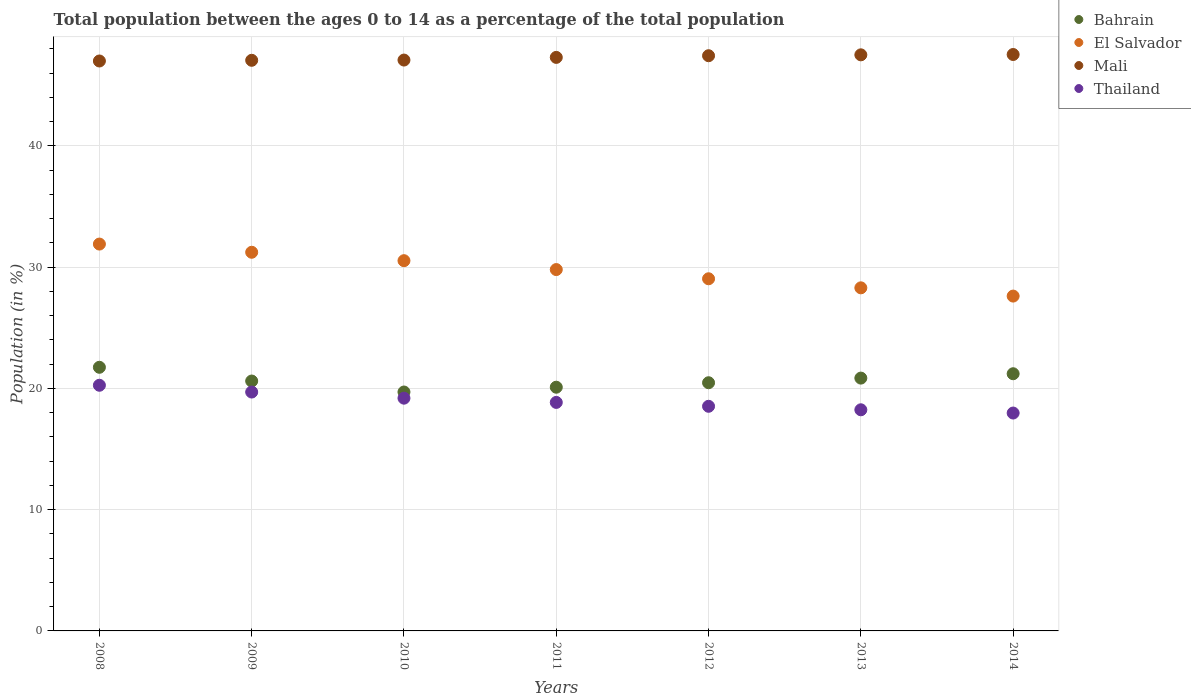What is the percentage of the population ages 0 to 14 in Mali in 2010?
Give a very brief answer. 47.08. Across all years, what is the maximum percentage of the population ages 0 to 14 in Thailand?
Provide a succinct answer. 20.26. Across all years, what is the minimum percentage of the population ages 0 to 14 in Thailand?
Your answer should be very brief. 17.97. What is the total percentage of the population ages 0 to 14 in Bahrain in the graph?
Your answer should be compact. 144.69. What is the difference between the percentage of the population ages 0 to 14 in Bahrain in 2009 and that in 2014?
Offer a terse response. -0.6. What is the difference between the percentage of the population ages 0 to 14 in Thailand in 2010 and the percentage of the population ages 0 to 14 in Bahrain in 2012?
Keep it short and to the point. -1.27. What is the average percentage of the population ages 0 to 14 in Bahrain per year?
Your response must be concise. 20.67. In the year 2014, what is the difference between the percentage of the population ages 0 to 14 in El Salvador and percentage of the population ages 0 to 14 in Mali?
Offer a terse response. -19.92. What is the ratio of the percentage of the population ages 0 to 14 in Mali in 2009 to that in 2010?
Keep it short and to the point. 1. Is the percentage of the population ages 0 to 14 in El Salvador in 2008 less than that in 2014?
Offer a terse response. No. Is the difference between the percentage of the population ages 0 to 14 in El Salvador in 2010 and 2012 greater than the difference between the percentage of the population ages 0 to 14 in Mali in 2010 and 2012?
Make the answer very short. Yes. What is the difference between the highest and the second highest percentage of the population ages 0 to 14 in El Salvador?
Give a very brief answer. 0.68. What is the difference between the highest and the lowest percentage of the population ages 0 to 14 in Mali?
Ensure brevity in your answer.  0.54. In how many years, is the percentage of the population ages 0 to 14 in Bahrain greater than the average percentage of the population ages 0 to 14 in Bahrain taken over all years?
Offer a terse response. 3. Does the percentage of the population ages 0 to 14 in Bahrain monotonically increase over the years?
Offer a very short reply. No. How many years are there in the graph?
Provide a succinct answer. 7. What is the difference between two consecutive major ticks on the Y-axis?
Your answer should be compact. 10. Are the values on the major ticks of Y-axis written in scientific E-notation?
Provide a succinct answer. No. Does the graph contain grids?
Offer a terse response. Yes. Where does the legend appear in the graph?
Keep it short and to the point. Top right. How many legend labels are there?
Make the answer very short. 4. How are the legend labels stacked?
Your answer should be compact. Vertical. What is the title of the graph?
Your answer should be compact. Total population between the ages 0 to 14 as a percentage of the total population. What is the label or title of the X-axis?
Provide a short and direct response. Years. What is the label or title of the Y-axis?
Your answer should be very brief. Population (in %). What is the Population (in %) in Bahrain in 2008?
Offer a terse response. 21.74. What is the Population (in %) of El Salvador in 2008?
Your answer should be compact. 31.91. What is the Population (in %) of Mali in 2008?
Your answer should be very brief. 47. What is the Population (in %) in Thailand in 2008?
Offer a very short reply. 20.26. What is the Population (in %) in Bahrain in 2009?
Provide a succinct answer. 20.61. What is the Population (in %) of El Salvador in 2009?
Your answer should be compact. 31.23. What is the Population (in %) of Mali in 2009?
Make the answer very short. 47.06. What is the Population (in %) of Thailand in 2009?
Offer a very short reply. 19.7. What is the Population (in %) of Bahrain in 2010?
Your answer should be very brief. 19.7. What is the Population (in %) in El Salvador in 2010?
Provide a succinct answer. 30.53. What is the Population (in %) of Mali in 2010?
Make the answer very short. 47.08. What is the Population (in %) of Thailand in 2010?
Give a very brief answer. 19.2. What is the Population (in %) in Bahrain in 2011?
Your answer should be compact. 20.1. What is the Population (in %) of El Salvador in 2011?
Your response must be concise. 29.8. What is the Population (in %) in Mali in 2011?
Keep it short and to the point. 47.3. What is the Population (in %) of Thailand in 2011?
Keep it short and to the point. 18.85. What is the Population (in %) of Bahrain in 2012?
Make the answer very short. 20.47. What is the Population (in %) of El Salvador in 2012?
Keep it short and to the point. 29.04. What is the Population (in %) of Mali in 2012?
Give a very brief answer. 47.44. What is the Population (in %) in Thailand in 2012?
Keep it short and to the point. 18.53. What is the Population (in %) in Bahrain in 2013?
Offer a very short reply. 20.85. What is the Population (in %) in El Salvador in 2013?
Give a very brief answer. 28.3. What is the Population (in %) in Mali in 2013?
Ensure brevity in your answer.  47.51. What is the Population (in %) of Thailand in 2013?
Ensure brevity in your answer.  18.24. What is the Population (in %) of Bahrain in 2014?
Give a very brief answer. 21.21. What is the Population (in %) in El Salvador in 2014?
Give a very brief answer. 27.62. What is the Population (in %) in Mali in 2014?
Give a very brief answer. 47.54. What is the Population (in %) in Thailand in 2014?
Provide a short and direct response. 17.97. Across all years, what is the maximum Population (in %) of Bahrain?
Offer a terse response. 21.74. Across all years, what is the maximum Population (in %) in El Salvador?
Your answer should be very brief. 31.91. Across all years, what is the maximum Population (in %) in Mali?
Provide a succinct answer. 47.54. Across all years, what is the maximum Population (in %) of Thailand?
Make the answer very short. 20.26. Across all years, what is the minimum Population (in %) of Bahrain?
Give a very brief answer. 19.7. Across all years, what is the minimum Population (in %) in El Salvador?
Your answer should be compact. 27.62. Across all years, what is the minimum Population (in %) of Mali?
Make the answer very short. 47. Across all years, what is the minimum Population (in %) of Thailand?
Your answer should be compact. 17.97. What is the total Population (in %) in Bahrain in the graph?
Provide a succinct answer. 144.69. What is the total Population (in %) in El Salvador in the graph?
Ensure brevity in your answer.  208.42. What is the total Population (in %) of Mali in the graph?
Make the answer very short. 330.94. What is the total Population (in %) of Thailand in the graph?
Offer a terse response. 132.74. What is the difference between the Population (in %) in Bahrain in 2008 and that in 2009?
Provide a short and direct response. 1.13. What is the difference between the Population (in %) of El Salvador in 2008 and that in 2009?
Your answer should be very brief. 0.68. What is the difference between the Population (in %) of Mali in 2008 and that in 2009?
Keep it short and to the point. -0.06. What is the difference between the Population (in %) of Thailand in 2008 and that in 2009?
Make the answer very short. 0.56. What is the difference between the Population (in %) of Bahrain in 2008 and that in 2010?
Offer a terse response. 2.04. What is the difference between the Population (in %) in El Salvador in 2008 and that in 2010?
Provide a short and direct response. 1.37. What is the difference between the Population (in %) of Mali in 2008 and that in 2010?
Ensure brevity in your answer.  -0.08. What is the difference between the Population (in %) of Thailand in 2008 and that in 2010?
Make the answer very short. 1.07. What is the difference between the Population (in %) of Bahrain in 2008 and that in 2011?
Give a very brief answer. 1.64. What is the difference between the Population (in %) of El Salvador in 2008 and that in 2011?
Offer a very short reply. 2.1. What is the difference between the Population (in %) of Mali in 2008 and that in 2011?
Ensure brevity in your answer.  -0.3. What is the difference between the Population (in %) in Thailand in 2008 and that in 2011?
Make the answer very short. 1.41. What is the difference between the Population (in %) of Bahrain in 2008 and that in 2012?
Your answer should be compact. 1.27. What is the difference between the Population (in %) in El Salvador in 2008 and that in 2012?
Keep it short and to the point. 2.86. What is the difference between the Population (in %) in Mali in 2008 and that in 2012?
Ensure brevity in your answer.  -0.43. What is the difference between the Population (in %) of Thailand in 2008 and that in 2012?
Provide a short and direct response. 1.73. What is the difference between the Population (in %) of Bahrain in 2008 and that in 2013?
Make the answer very short. 0.89. What is the difference between the Population (in %) of El Salvador in 2008 and that in 2013?
Your answer should be very brief. 3.61. What is the difference between the Population (in %) of Mali in 2008 and that in 2013?
Keep it short and to the point. -0.51. What is the difference between the Population (in %) in Thailand in 2008 and that in 2013?
Offer a very short reply. 2.02. What is the difference between the Population (in %) of Bahrain in 2008 and that in 2014?
Offer a very short reply. 0.53. What is the difference between the Population (in %) of El Salvador in 2008 and that in 2014?
Your answer should be compact. 4.29. What is the difference between the Population (in %) of Mali in 2008 and that in 2014?
Give a very brief answer. -0.54. What is the difference between the Population (in %) of Thailand in 2008 and that in 2014?
Ensure brevity in your answer.  2.29. What is the difference between the Population (in %) in Bahrain in 2009 and that in 2010?
Keep it short and to the point. 0.91. What is the difference between the Population (in %) in El Salvador in 2009 and that in 2010?
Offer a terse response. 0.69. What is the difference between the Population (in %) in Mali in 2009 and that in 2010?
Your response must be concise. -0.02. What is the difference between the Population (in %) in Thailand in 2009 and that in 2010?
Your answer should be very brief. 0.51. What is the difference between the Population (in %) of Bahrain in 2009 and that in 2011?
Keep it short and to the point. 0.51. What is the difference between the Population (in %) of El Salvador in 2009 and that in 2011?
Offer a very short reply. 1.43. What is the difference between the Population (in %) in Mali in 2009 and that in 2011?
Give a very brief answer. -0.24. What is the difference between the Population (in %) of Thailand in 2009 and that in 2011?
Ensure brevity in your answer.  0.86. What is the difference between the Population (in %) of Bahrain in 2009 and that in 2012?
Provide a succinct answer. 0.14. What is the difference between the Population (in %) of El Salvador in 2009 and that in 2012?
Your answer should be compact. 2.19. What is the difference between the Population (in %) of Mali in 2009 and that in 2012?
Your answer should be very brief. -0.38. What is the difference between the Population (in %) of Thailand in 2009 and that in 2012?
Your response must be concise. 1.17. What is the difference between the Population (in %) in Bahrain in 2009 and that in 2013?
Give a very brief answer. -0.24. What is the difference between the Population (in %) of El Salvador in 2009 and that in 2013?
Keep it short and to the point. 2.93. What is the difference between the Population (in %) of Mali in 2009 and that in 2013?
Keep it short and to the point. -0.45. What is the difference between the Population (in %) in Thailand in 2009 and that in 2013?
Your answer should be compact. 1.46. What is the difference between the Population (in %) in Bahrain in 2009 and that in 2014?
Keep it short and to the point. -0.6. What is the difference between the Population (in %) in El Salvador in 2009 and that in 2014?
Keep it short and to the point. 3.61. What is the difference between the Population (in %) of Mali in 2009 and that in 2014?
Ensure brevity in your answer.  -0.48. What is the difference between the Population (in %) of Thailand in 2009 and that in 2014?
Provide a short and direct response. 1.73. What is the difference between the Population (in %) in Bahrain in 2010 and that in 2011?
Provide a short and direct response. -0.39. What is the difference between the Population (in %) in El Salvador in 2010 and that in 2011?
Your response must be concise. 0.73. What is the difference between the Population (in %) of Mali in 2010 and that in 2011?
Keep it short and to the point. -0.22. What is the difference between the Population (in %) of Thailand in 2010 and that in 2011?
Give a very brief answer. 0.35. What is the difference between the Population (in %) in Bahrain in 2010 and that in 2012?
Provide a succinct answer. -0.76. What is the difference between the Population (in %) of El Salvador in 2010 and that in 2012?
Offer a very short reply. 1.49. What is the difference between the Population (in %) in Mali in 2010 and that in 2012?
Offer a terse response. -0.36. What is the difference between the Population (in %) in Thailand in 2010 and that in 2012?
Provide a short and direct response. 0.67. What is the difference between the Population (in %) in Bahrain in 2010 and that in 2013?
Provide a short and direct response. -1.15. What is the difference between the Population (in %) in El Salvador in 2010 and that in 2013?
Provide a succinct answer. 2.24. What is the difference between the Population (in %) of Mali in 2010 and that in 2013?
Provide a short and direct response. -0.43. What is the difference between the Population (in %) in Thailand in 2010 and that in 2013?
Offer a very short reply. 0.96. What is the difference between the Population (in %) of Bahrain in 2010 and that in 2014?
Ensure brevity in your answer.  -1.51. What is the difference between the Population (in %) in El Salvador in 2010 and that in 2014?
Keep it short and to the point. 2.92. What is the difference between the Population (in %) in Mali in 2010 and that in 2014?
Provide a succinct answer. -0.46. What is the difference between the Population (in %) in Thailand in 2010 and that in 2014?
Provide a short and direct response. 1.23. What is the difference between the Population (in %) of Bahrain in 2011 and that in 2012?
Keep it short and to the point. -0.37. What is the difference between the Population (in %) of El Salvador in 2011 and that in 2012?
Ensure brevity in your answer.  0.76. What is the difference between the Population (in %) in Mali in 2011 and that in 2012?
Give a very brief answer. -0.14. What is the difference between the Population (in %) in Thailand in 2011 and that in 2012?
Your response must be concise. 0.32. What is the difference between the Population (in %) in Bahrain in 2011 and that in 2013?
Your response must be concise. -0.75. What is the difference between the Population (in %) in El Salvador in 2011 and that in 2013?
Offer a very short reply. 1.51. What is the difference between the Population (in %) in Mali in 2011 and that in 2013?
Provide a succinct answer. -0.21. What is the difference between the Population (in %) of Thailand in 2011 and that in 2013?
Make the answer very short. 0.61. What is the difference between the Population (in %) of Bahrain in 2011 and that in 2014?
Provide a short and direct response. -1.11. What is the difference between the Population (in %) in El Salvador in 2011 and that in 2014?
Keep it short and to the point. 2.19. What is the difference between the Population (in %) of Mali in 2011 and that in 2014?
Your response must be concise. -0.24. What is the difference between the Population (in %) of Thailand in 2011 and that in 2014?
Provide a short and direct response. 0.88. What is the difference between the Population (in %) in Bahrain in 2012 and that in 2013?
Your response must be concise. -0.38. What is the difference between the Population (in %) in El Salvador in 2012 and that in 2013?
Ensure brevity in your answer.  0.75. What is the difference between the Population (in %) in Mali in 2012 and that in 2013?
Your response must be concise. -0.07. What is the difference between the Population (in %) in Thailand in 2012 and that in 2013?
Give a very brief answer. 0.29. What is the difference between the Population (in %) in Bahrain in 2012 and that in 2014?
Your response must be concise. -0.74. What is the difference between the Population (in %) of El Salvador in 2012 and that in 2014?
Keep it short and to the point. 1.43. What is the difference between the Population (in %) of Mali in 2012 and that in 2014?
Your answer should be very brief. -0.1. What is the difference between the Population (in %) of Thailand in 2012 and that in 2014?
Your response must be concise. 0.56. What is the difference between the Population (in %) in Bahrain in 2013 and that in 2014?
Your answer should be very brief. -0.36. What is the difference between the Population (in %) of El Salvador in 2013 and that in 2014?
Offer a very short reply. 0.68. What is the difference between the Population (in %) of Mali in 2013 and that in 2014?
Provide a short and direct response. -0.03. What is the difference between the Population (in %) of Thailand in 2013 and that in 2014?
Offer a very short reply. 0.27. What is the difference between the Population (in %) in Bahrain in 2008 and the Population (in %) in El Salvador in 2009?
Keep it short and to the point. -9.49. What is the difference between the Population (in %) of Bahrain in 2008 and the Population (in %) of Mali in 2009?
Give a very brief answer. -25.32. What is the difference between the Population (in %) in Bahrain in 2008 and the Population (in %) in Thailand in 2009?
Provide a short and direct response. 2.04. What is the difference between the Population (in %) in El Salvador in 2008 and the Population (in %) in Mali in 2009?
Make the answer very short. -15.16. What is the difference between the Population (in %) in El Salvador in 2008 and the Population (in %) in Thailand in 2009?
Offer a very short reply. 12.2. What is the difference between the Population (in %) in Mali in 2008 and the Population (in %) in Thailand in 2009?
Ensure brevity in your answer.  27.3. What is the difference between the Population (in %) of Bahrain in 2008 and the Population (in %) of El Salvador in 2010?
Your answer should be very brief. -8.79. What is the difference between the Population (in %) in Bahrain in 2008 and the Population (in %) in Mali in 2010?
Offer a terse response. -25.34. What is the difference between the Population (in %) in Bahrain in 2008 and the Population (in %) in Thailand in 2010?
Your answer should be very brief. 2.55. What is the difference between the Population (in %) in El Salvador in 2008 and the Population (in %) in Mali in 2010?
Give a very brief answer. -15.18. What is the difference between the Population (in %) in El Salvador in 2008 and the Population (in %) in Thailand in 2010?
Offer a very short reply. 12.71. What is the difference between the Population (in %) of Mali in 2008 and the Population (in %) of Thailand in 2010?
Your answer should be compact. 27.81. What is the difference between the Population (in %) in Bahrain in 2008 and the Population (in %) in El Salvador in 2011?
Provide a short and direct response. -8.06. What is the difference between the Population (in %) of Bahrain in 2008 and the Population (in %) of Mali in 2011?
Give a very brief answer. -25.56. What is the difference between the Population (in %) of Bahrain in 2008 and the Population (in %) of Thailand in 2011?
Provide a short and direct response. 2.9. What is the difference between the Population (in %) of El Salvador in 2008 and the Population (in %) of Mali in 2011?
Your answer should be very brief. -15.4. What is the difference between the Population (in %) of El Salvador in 2008 and the Population (in %) of Thailand in 2011?
Give a very brief answer. 13.06. What is the difference between the Population (in %) in Mali in 2008 and the Population (in %) in Thailand in 2011?
Keep it short and to the point. 28.16. What is the difference between the Population (in %) of Bahrain in 2008 and the Population (in %) of El Salvador in 2012?
Keep it short and to the point. -7.3. What is the difference between the Population (in %) of Bahrain in 2008 and the Population (in %) of Mali in 2012?
Keep it short and to the point. -25.7. What is the difference between the Population (in %) of Bahrain in 2008 and the Population (in %) of Thailand in 2012?
Your answer should be compact. 3.22. What is the difference between the Population (in %) in El Salvador in 2008 and the Population (in %) in Mali in 2012?
Keep it short and to the point. -15.53. What is the difference between the Population (in %) of El Salvador in 2008 and the Population (in %) of Thailand in 2012?
Your answer should be compact. 13.38. What is the difference between the Population (in %) in Mali in 2008 and the Population (in %) in Thailand in 2012?
Ensure brevity in your answer.  28.48. What is the difference between the Population (in %) in Bahrain in 2008 and the Population (in %) in El Salvador in 2013?
Ensure brevity in your answer.  -6.55. What is the difference between the Population (in %) in Bahrain in 2008 and the Population (in %) in Mali in 2013?
Your answer should be compact. -25.77. What is the difference between the Population (in %) of Bahrain in 2008 and the Population (in %) of Thailand in 2013?
Make the answer very short. 3.51. What is the difference between the Population (in %) in El Salvador in 2008 and the Population (in %) in Mali in 2013?
Your answer should be compact. -15.61. What is the difference between the Population (in %) in El Salvador in 2008 and the Population (in %) in Thailand in 2013?
Give a very brief answer. 13.67. What is the difference between the Population (in %) in Mali in 2008 and the Population (in %) in Thailand in 2013?
Your response must be concise. 28.77. What is the difference between the Population (in %) in Bahrain in 2008 and the Population (in %) in El Salvador in 2014?
Your answer should be very brief. -5.87. What is the difference between the Population (in %) of Bahrain in 2008 and the Population (in %) of Mali in 2014?
Ensure brevity in your answer.  -25.8. What is the difference between the Population (in %) in Bahrain in 2008 and the Population (in %) in Thailand in 2014?
Your response must be concise. 3.77. What is the difference between the Population (in %) in El Salvador in 2008 and the Population (in %) in Mali in 2014?
Keep it short and to the point. -15.63. What is the difference between the Population (in %) in El Salvador in 2008 and the Population (in %) in Thailand in 2014?
Your answer should be compact. 13.94. What is the difference between the Population (in %) of Mali in 2008 and the Population (in %) of Thailand in 2014?
Provide a short and direct response. 29.03. What is the difference between the Population (in %) in Bahrain in 2009 and the Population (in %) in El Salvador in 2010?
Ensure brevity in your answer.  -9.93. What is the difference between the Population (in %) in Bahrain in 2009 and the Population (in %) in Mali in 2010?
Offer a very short reply. -26.47. What is the difference between the Population (in %) of Bahrain in 2009 and the Population (in %) of Thailand in 2010?
Ensure brevity in your answer.  1.41. What is the difference between the Population (in %) in El Salvador in 2009 and the Population (in %) in Mali in 2010?
Keep it short and to the point. -15.85. What is the difference between the Population (in %) in El Salvador in 2009 and the Population (in %) in Thailand in 2010?
Your answer should be compact. 12.03. What is the difference between the Population (in %) in Mali in 2009 and the Population (in %) in Thailand in 2010?
Provide a succinct answer. 27.87. What is the difference between the Population (in %) in Bahrain in 2009 and the Population (in %) in El Salvador in 2011?
Provide a succinct answer. -9.19. What is the difference between the Population (in %) of Bahrain in 2009 and the Population (in %) of Mali in 2011?
Ensure brevity in your answer.  -26.69. What is the difference between the Population (in %) in Bahrain in 2009 and the Population (in %) in Thailand in 2011?
Ensure brevity in your answer.  1.76. What is the difference between the Population (in %) of El Salvador in 2009 and the Population (in %) of Mali in 2011?
Keep it short and to the point. -16.07. What is the difference between the Population (in %) of El Salvador in 2009 and the Population (in %) of Thailand in 2011?
Give a very brief answer. 12.38. What is the difference between the Population (in %) in Mali in 2009 and the Population (in %) in Thailand in 2011?
Offer a terse response. 28.22. What is the difference between the Population (in %) of Bahrain in 2009 and the Population (in %) of El Salvador in 2012?
Offer a very short reply. -8.43. What is the difference between the Population (in %) of Bahrain in 2009 and the Population (in %) of Mali in 2012?
Your answer should be compact. -26.83. What is the difference between the Population (in %) of Bahrain in 2009 and the Population (in %) of Thailand in 2012?
Give a very brief answer. 2.08. What is the difference between the Population (in %) in El Salvador in 2009 and the Population (in %) in Mali in 2012?
Provide a short and direct response. -16.21. What is the difference between the Population (in %) of El Salvador in 2009 and the Population (in %) of Thailand in 2012?
Provide a short and direct response. 12.7. What is the difference between the Population (in %) in Mali in 2009 and the Population (in %) in Thailand in 2012?
Provide a succinct answer. 28.53. What is the difference between the Population (in %) in Bahrain in 2009 and the Population (in %) in El Salvador in 2013?
Offer a very short reply. -7.69. What is the difference between the Population (in %) in Bahrain in 2009 and the Population (in %) in Mali in 2013?
Your response must be concise. -26.9. What is the difference between the Population (in %) in Bahrain in 2009 and the Population (in %) in Thailand in 2013?
Your answer should be very brief. 2.37. What is the difference between the Population (in %) of El Salvador in 2009 and the Population (in %) of Mali in 2013?
Make the answer very short. -16.28. What is the difference between the Population (in %) of El Salvador in 2009 and the Population (in %) of Thailand in 2013?
Ensure brevity in your answer.  12.99. What is the difference between the Population (in %) in Mali in 2009 and the Population (in %) in Thailand in 2013?
Your answer should be very brief. 28.82. What is the difference between the Population (in %) of Bahrain in 2009 and the Population (in %) of El Salvador in 2014?
Ensure brevity in your answer.  -7.01. What is the difference between the Population (in %) of Bahrain in 2009 and the Population (in %) of Mali in 2014?
Offer a very short reply. -26.93. What is the difference between the Population (in %) of Bahrain in 2009 and the Population (in %) of Thailand in 2014?
Provide a short and direct response. 2.64. What is the difference between the Population (in %) in El Salvador in 2009 and the Population (in %) in Mali in 2014?
Keep it short and to the point. -16.31. What is the difference between the Population (in %) of El Salvador in 2009 and the Population (in %) of Thailand in 2014?
Ensure brevity in your answer.  13.26. What is the difference between the Population (in %) of Mali in 2009 and the Population (in %) of Thailand in 2014?
Keep it short and to the point. 29.09. What is the difference between the Population (in %) of Bahrain in 2010 and the Population (in %) of El Salvador in 2011?
Your answer should be compact. -10.1. What is the difference between the Population (in %) of Bahrain in 2010 and the Population (in %) of Mali in 2011?
Make the answer very short. -27.6. What is the difference between the Population (in %) of Bahrain in 2010 and the Population (in %) of Thailand in 2011?
Your answer should be very brief. 0.86. What is the difference between the Population (in %) in El Salvador in 2010 and the Population (in %) in Mali in 2011?
Offer a very short reply. -16.77. What is the difference between the Population (in %) in El Salvador in 2010 and the Population (in %) in Thailand in 2011?
Keep it short and to the point. 11.69. What is the difference between the Population (in %) in Mali in 2010 and the Population (in %) in Thailand in 2011?
Provide a succinct answer. 28.24. What is the difference between the Population (in %) of Bahrain in 2010 and the Population (in %) of El Salvador in 2012?
Keep it short and to the point. -9.34. What is the difference between the Population (in %) in Bahrain in 2010 and the Population (in %) in Mali in 2012?
Keep it short and to the point. -27.73. What is the difference between the Population (in %) in Bahrain in 2010 and the Population (in %) in Thailand in 2012?
Make the answer very short. 1.18. What is the difference between the Population (in %) in El Salvador in 2010 and the Population (in %) in Mali in 2012?
Your answer should be very brief. -16.9. What is the difference between the Population (in %) of El Salvador in 2010 and the Population (in %) of Thailand in 2012?
Your answer should be very brief. 12.01. What is the difference between the Population (in %) in Mali in 2010 and the Population (in %) in Thailand in 2012?
Your answer should be compact. 28.55. What is the difference between the Population (in %) in Bahrain in 2010 and the Population (in %) in El Salvador in 2013?
Offer a terse response. -8.59. What is the difference between the Population (in %) in Bahrain in 2010 and the Population (in %) in Mali in 2013?
Offer a very short reply. -27.81. What is the difference between the Population (in %) of Bahrain in 2010 and the Population (in %) of Thailand in 2013?
Your answer should be very brief. 1.47. What is the difference between the Population (in %) in El Salvador in 2010 and the Population (in %) in Mali in 2013?
Your response must be concise. -16.98. What is the difference between the Population (in %) in El Salvador in 2010 and the Population (in %) in Thailand in 2013?
Your answer should be very brief. 12.3. What is the difference between the Population (in %) in Mali in 2010 and the Population (in %) in Thailand in 2013?
Offer a terse response. 28.84. What is the difference between the Population (in %) in Bahrain in 2010 and the Population (in %) in El Salvador in 2014?
Offer a terse response. -7.91. What is the difference between the Population (in %) in Bahrain in 2010 and the Population (in %) in Mali in 2014?
Ensure brevity in your answer.  -27.83. What is the difference between the Population (in %) of Bahrain in 2010 and the Population (in %) of Thailand in 2014?
Provide a short and direct response. 1.73. What is the difference between the Population (in %) in El Salvador in 2010 and the Population (in %) in Mali in 2014?
Make the answer very short. -17. What is the difference between the Population (in %) of El Salvador in 2010 and the Population (in %) of Thailand in 2014?
Your answer should be compact. 12.57. What is the difference between the Population (in %) in Mali in 2010 and the Population (in %) in Thailand in 2014?
Your answer should be compact. 29.11. What is the difference between the Population (in %) of Bahrain in 2011 and the Population (in %) of El Salvador in 2012?
Your answer should be compact. -8.94. What is the difference between the Population (in %) of Bahrain in 2011 and the Population (in %) of Mali in 2012?
Provide a succinct answer. -27.34. What is the difference between the Population (in %) of Bahrain in 2011 and the Population (in %) of Thailand in 2012?
Your answer should be very brief. 1.57. What is the difference between the Population (in %) in El Salvador in 2011 and the Population (in %) in Mali in 2012?
Your response must be concise. -17.64. What is the difference between the Population (in %) in El Salvador in 2011 and the Population (in %) in Thailand in 2012?
Provide a short and direct response. 11.28. What is the difference between the Population (in %) of Mali in 2011 and the Population (in %) of Thailand in 2012?
Keep it short and to the point. 28.77. What is the difference between the Population (in %) of Bahrain in 2011 and the Population (in %) of El Salvador in 2013?
Keep it short and to the point. -8.2. What is the difference between the Population (in %) of Bahrain in 2011 and the Population (in %) of Mali in 2013?
Offer a terse response. -27.41. What is the difference between the Population (in %) of Bahrain in 2011 and the Population (in %) of Thailand in 2013?
Your answer should be very brief. 1.86. What is the difference between the Population (in %) in El Salvador in 2011 and the Population (in %) in Mali in 2013?
Ensure brevity in your answer.  -17.71. What is the difference between the Population (in %) of El Salvador in 2011 and the Population (in %) of Thailand in 2013?
Offer a terse response. 11.56. What is the difference between the Population (in %) in Mali in 2011 and the Population (in %) in Thailand in 2013?
Your answer should be compact. 29.06. What is the difference between the Population (in %) in Bahrain in 2011 and the Population (in %) in El Salvador in 2014?
Your response must be concise. -7.52. What is the difference between the Population (in %) of Bahrain in 2011 and the Population (in %) of Mali in 2014?
Offer a very short reply. -27.44. What is the difference between the Population (in %) in Bahrain in 2011 and the Population (in %) in Thailand in 2014?
Give a very brief answer. 2.13. What is the difference between the Population (in %) of El Salvador in 2011 and the Population (in %) of Mali in 2014?
Make the answer very short. -17.74. What is the difference between the Population (in %) of El Salvador in 2011 and the Population (in %) of Thailand in 2014?
Offer a terse response. 11.83. What is the difference between the Population (in %) of Mali in 2011 and the Population (in %) of Thailand in 2014?
Your answer should be compact. 29.33. What is the difference between the Population (in %) of Bahrain in 2012 and the Population (in %) of El Salvador in 2013?
Your answer should be compact. -7.83. What is the difference between the Population (in %) of Bahrain in 2012 and the Population (in %) of Mali in 2013?
Offer a very short reply. -27.04. What is the difference between the Population (in %) of Bahrain in 2012 and the Population (in %) of Thailand in 2013?
Keep it short and to the point. 2.23. What is the difference between the Population (in %) in El Salvador in 2012 and the Population (in %) in Mali in 2013?
Offer a very short reply. -18.47. What is the difference between the Population (in %) of El Salvador in 2012 and the Population (in %) of Thailand in 2013?
Provide a succinct answer. 10.81. What is the difference between the Population (in %) of Mali in 2012 and the Population (in %) of Thailand in 2013?
Provide a succinct answer. 29.2. What is the difference between the Population (in %) in Bahrain in 2012 and the Population (in %) in El Salvador in 2014?
Give a very brief answer. -7.15. What is the difference between the Population (in %) in Bahrain in 2012 and the Population (in %) in Mali in 2014?
Your response must be concise. -27.07. What is the difference between the Population (in %) in Bahrain in 2012 and the Population (in %) in Thailand in 2014?
Your response must be concise. 2.5. What is the difference between the Population (in %) in El Salvador in 2012 and the Population (in %) in Mali in 2014?
Offer a terse response. -18.5. What is the difference between the Population (in %) of El Salvador in 2012 and the Population (in %) of Thailand in 2014?
Your answer should be very brief. 11.07. What is the difference between the Population (in %) of Mali in 2012 and the Population (in %) of Thailand in 2014?
Keep it short and to the point. 29.47. What is the difference between the Population (in %) in Bahrain in 2013 and the Population (in %) in El Salvador in 2014?
Keep it short and to the point. -6.76. What is the difference between the Population (in %) in Bahrain in 2013 and the Population (in %) in Mali in 2014?
Provide a succinct answer. -26.69. What is the difference between the Population (in %) in Bahrain in 2013 and the Population (in %) in Thailand in 2014?
Provide a succinct answer. 2.88. What is the difference between the Population (in %) in El Salvador in 2013 and the Population (in %) in Mali in 2014?
Offer a terse response. -19.24. What is the difference between the Population (in %) in El Salvador in 2013 and the Population (in %) in Thailand in 2014?
Your answer should be compact. 10.33. What is the difference between the Population (in %) in Mali in 2013 and the Population (in %) in Thailand in 2014?
Your response must be concise. 29.54. What is the average Population (in %) in Bahrain per year?
Provide a short and direct response. 20.67. What is the average Population (in %) in El Salvador per year?
Make the answer very short. 29.77. What is the average Population (in %) in Mali per year?
Provide a succinct answer. 47.28. What is the average Population (in %) of Thailand per year?
Keep it short and to the point. 18.96. In the year 2008, what is the difference between the Population (in %) of Bahrain and Population (in %) of El Salvador?
Offer a terse response. -10.16. In the year 2008, what is the difference between the Population (in %) in Bahrain and Population (in %) in Mali?
Ensure brevity in your answer.  -25.26. In the year 2008, what is the difference between the Population (in %) in Bahrain and Population (in %) in Thailand?
Give a very brief answer. 1.48. In the year 2008, what is the difference between the Population (in %) in El Salvador and Population (in %) in Mali?
Offer a very short reply. -15.1. In the year 2008, what is the difference between the Population (in %) of El Salvador and Population (in %) of Thailand?
Ensure brevity in your answer.  11.64. In the year 2008, what is the difference between the Population (in %) of Mali and Population (in %) of Thailand?
Provide a succinct answer. 26.74. In the year 2009, what is the difference between the Population (in %) in Bahrain and Population (in %) in El Salvador?
Make the answer very short. -10.62. In the year 2009, what is the difference between the Population (in %) in Bahrain and Population (in %) in Mali?
Your answer should be very brief. -26.45. In the year 2009, what is the difference between the Population (in %) in Bahrain and Population (in %) in Thailand?
Give a very brief answer. 0.91. In the year 2009, what is the difference between the Population (in %) in El Salvador and Population (in %) in Mali?
Make the answer very short. -15.83. In the year 2009, what is the difference between the Population (in %) in El Salvador and Population (in %) in Thailand?
Your response must be concise. 11.53. In the year 2009, what is the difference between the Population (in %) of Mali and Population (in %) of Thailand?
Give a very brief answer. 27.36. In the year 2010, what is the difference between the Population (in %) of Bahrain and Population (in %) of El Salvador?
Ensure brevity in your answer.  -10.83. In the year 2010, what is the difference between the Population (in %) of Bahrain and Population (in %) of Mali?
Your answer should be compact. -27.38. In the year 2010, what is the difference between the Population (in %) in Bahrain and Population (in %) in Thailand?
Ensure brevity in your answer.  0.51. In the year 2010, what is the difference between the Population (in %) in El Salvador and Population (in %) in Mali?
Offer a terse response. -16.55. In the year 2010, what is the difference between the Population (in %) of El Salvador and Population (in %) of Thailand?
Make the answer very short. 11.34. In the year 2010, what is the difference between the Population (in %) in Mali and Population (in %) in Thailand?
Offer a very short reply. 27.89. In the year 2011, what is the difference between the Population (in %) of Bahrain and Population (in %) of El Salvador?
Ensure brevity in your answer.  -9.7. In the year 2011, what is the difference between the Population (in %) in Bahrain and Population (in %) in Mali?
Provide a succinct answer. -27.2. In the year 2011, what is the difference between the Population (in %) in Bahrain and Population (in %) in Thailand?
Keep it short and to the point. 1.25. In the year 2011, what is the difference between the Population (in %) of El Salvador and Population (in %) of Mali?
Your answer should be very brief. -17.5. In the year 2011, what is the difference between the Population (in %) of El Salvador and Population (in %) of Thailand?
Provide a succinct answer. 10.96. In the year 2011, what is the difference between the Population (in %) in Mali and Population (in %) in Thailand?
Your response must be concise. 28.46. In the year 2012, what is the difference between the Population (in %) in Bahrain and Population (in %) in El Salvador?
Offer a terse response. -8.57. In the year 2012, what is the difference between the Population (in %) of Bahrain and Population (in %) of Mali?
Offer a terse response. -26.97. In the year 2012, what is the difference between the Population (in %) in Bahrain and Population (in %) in Thailand?
Your answer should be compact. 1.94. In the year 2012, what is the difference between the Population (in %) in El Salvador and Population (in %) in Mali?
Your answer should be very brief. -18.4. In the year 2012, what is the difference between the Population (in %) of El Salvador and Population (in %) of Thailand?
Give a very brief answer. 10.52. In the year 2012, what is the difference between the Population (in %) in Mali and Population (in %) in Thailand?
Your answer should be compact. 28.91. In the year 2013, what is the difference between the Population (in %) of Bahrain and Population (in %) of El Salvador?
Give a very brief answer. -7.44. In the year 2013, what is the difference between the Population (in %) of Bahrain and Population (in %) of Mali?
Give a very brief answer. -26.66. In the year 2013, what is the difference between the Population (in %) of Bahrain and Population (in %) of Thailand?
Provide a short and direct response. 2.61. In the year 2013, what is the difference between the Population (in %) in El Salvador and Population (in %) in Mali?
Your answer should be compact. -19.22. In the year 2013, what is the difference between the Population (in %) of El Salvador and Population (in %) of Thailand?
Your answer should be compact. 10.06. In the year 2013, what is the difference between the Population (in %) in Mali and Population (in %) in Thailand?
Provide a short and direct response. 29.27. In the year 2014, what is the difference between the Population (in %) in Bahrain and Population (in %) in El Salvador?
Your answer should be compact. -6.4. In the year 2014, what is the difference between the Population (in %) in Bahrain and Population (in %) in Mali?
Keep it short and to the point. -26.33. In the year 2014, what is the difference between the Population (in %) of Bahrain and Population (in %) of Thailand?
Your response must be concise. 3.24. In the year 2014, what is the difference between the Population (in %) in El Salvador and Population (in %) in Mali?
Provide a short and direct response. -19.92. In the year 2014, what is the difference between the Population (in %) in El Salvador and Population (in %) in Thailand?
Your answer should be compact. 9.65. In the year 2014, what is the difference between the Population (in %) in Mali and Population (in %) in Thailand?
Your answer should be very brief. 29.57. What is the ratio of the Population (in %) in Bahrain in 2008 to that in 2009?
Provide a succinct answer. 1.05. What is the ratio of the Population (in %) of El Salvador in 2008 to that in 2009?
Your answer should be compact. 1.02. What is the ratio of the Population (in %) in Mali in 2008 to that in 2009?
Your answer should be compact. 1. What is the ratio of the Population (in %) in Thailand in 2008 to that in 2009?
Ensure brevity in your answer.  1.03. What is the ratio of the Population (in %) of Bahrain in 2008 to that in 2010?
Provide a succinct answer. 1.1. What is the ratio of the Population (in %) in El Salvador in 2008 to that in 2010?
Give a very brief answer. 1.04. What is the ratio of the Population (in %) in Mali in 2008 to that in 2010?
Offer a very short reply. 1. What is the ratio of the Population (in %) of Thailand in 2008 to that in 2010?
Your answer should be very brief. 1.06. What is the ratio of the Population (in %) of Bahrain in 2008 to that in 2011?
Your response must be concise. 1.08. What is the ratio of the Population (in %) in El Salvador in 2008 to that in 2011?
Make the answer very short. 1.07. What is the ratio of the Population (in %) in Mali in 2008 to that in 2011?
Your response must be concise. 0.99. What is the ratio of the Population (in %) of Thailand in 2008 to that in 2011?
Provide a succinct answer. 1.08. What is the ratio of the Population (in %) of Bahrain in 2008 to that in 2012?
Ensure brevity in your answer.  1.06. What is the ratio of the Population (in %) of El Salvador in 2008 to that in 2012?
Offer a terse response. 1.1. What is the ratio of the Population (in %) in Thailand in 2008 to that in 2012?
Make the answer very short. 1.09. What is the ratio of the Population (in %) of Bahrain in 2008 to that in 2013?
Give a very brief answer. 1.04. What is the ratio of the Population (in %) of El Salvador in 2008 to that in 2013?
Your response must be concise. 1.13. What is the ratio of the Population (in %) in Mali in 2008 to that in 2013?
Make the answer very short. 0.99. What is the ratio of the Population (in %) in Thailand in 2008 to that in 2013?
Provide a short and direct response. 1.11. What is the ratio of the Population (in %) of Bahrain in 2008 to that in 2014?
Provide a short and direct response. 1.03. What is the ratio of the Population (in %) in El Salvador in 2008 to that in 2014?
Your response must be concise. 1.16. What is the ratio of the Population (in %) of Mali in 2008 to that in 2014?
Your answer should be very brief. 0.99. What is the ratio of the Population (in %) of Thailand in 2008 to that in 2014?
Keep it short and to the point. 1.13. What is the ratio of the Population (in %) of Bahrain in 2009 to that in 2010?
Provide a short and direct response. 1.05. What is the ratio of the Population (in %) in El Salvador in 2009 to that in 2010?
Ensure brevity in your answer.  1.02. What is the ratio of the Population (in %) of Mali in 2009 to that in 2010?
Provide a succinct answer. 1. What is the ratio of the Population (in %) of Thailand in 2009 to that in 2010?
Your response must be concise. 1.03. What is the ratio of the Population (in %) of Bahrain in 2009 to that in 2011?
Make the answer very short. 1.03. What is the ratio of the Population (in %) in El Salvador in 2009 to that in 2011?
Offer a very short reply. 1.05. What is the ratio of the Population (in %) in Thailand in 2009 to that in 2011?
Provide a short and direct response. 1.05. What is the ratio of the Population (in %) in El Salvador in 2009 to that in 2012?
Your answer should be very brief. 1.08. What is the ratio of the Population (in %) of Mali in 2009 to that in 2012?
Keep it short and to the point. 0.99. What is the ratio of the Population (in %) in Thailand in 2009 to that in 2012?
Provide a succinct answer. 1.06. What is the ratio of the Population (in %) of Bahrain in 2009 to that in 2013?
Ensure brevity in your answer.  0.99. What is the ratio of the Population (in %) of El Salvador in 2009 to that in 2013?
Your answer should be compact. 1.1. What is the ratio of the Population (in %) in Mali in 2009 to that in 2013?
Make the answer very short. 0.99. What is the ratio of the Population (in %) of Thailand in 2009 to that in 2013?
Give a very brief answer. 1.08. What is the ratio of the Population (in %) of Bahrain in 2009 to that in 2014?
Make the answer very short. 0.97. What is the ratio of the Population (in %) in El Salvador in 2009 to that in 2014?
Your answer should be very brief. 1.13. What is the ratio of the Population (in %) in Mali in 2009 to that in 2014?
Your response must be concise. 0.99. What is the ratio of the Population (in %) of Thailand in 2009 to that in 2014?
Provide a short and direct response. 1.1. What is the ratio of the Population (in %) in Bahrain in 2010 to that in 2011?
Offer a very short reply. 0.98. What is the ratio of the Population (in %) in El Salvador in 2010 to that in 2011?
Provide a succinct answer. 1.02. What is the ratio of the Population (in %) in Thailand in 2010 to that in 2011?
Offer a very short reply. 1.02. What is the ratio of the Population (in %) in Bahrain in 2010 to that in 2012?
Make the answer very short. 0.96. What is the ratio of the Population (in %) in El Salvador in 2010 to that in 2012?
Give a very brief answer. 1.05. What is the ratio of the Population (in %) in Thailand in 2010 to that in 2012?
Your response must be concise. 1.04. What is the ratio of the Population (in %) in Bahrain in 2010 to that in 2013?
Your answer should be compact. 0.94. What is the ratio of the Population (in %) in El Salvador in 2010 to that in 2013?
Give a very brief answer. 1.08. What is the ratio of the Population (in %) of Mali in 2010 to that in 2013?
Keep it short and to the point. 0.99. What is the ratio of the Population (in %) in Thailand in 2010 to that in 2013?
Give a very brief answer. 1.05. What is the ratio of the Population (in %) of Bahrain in 2010 to that in 2014?
Make the answer very short. 0.93. What is the ratio of the Population (in %) of El Salvador in 2010 to that in 2014?
Offer a terse response. 1.11. What is the ratio of the Population (in %) of Mali in 2010 to that in 2014?
Ensure brevity in your answer.  0.99. What is the ratio of the Population (in %) in Thailand in 2010 to that in 2014?
Keep it short and to the point. 1.07. What is the ratio of the Population (in %) in Bahrain in 2011 to that in 2012?
Ensure brevity in your answer.  0.98. What is the ratio of the Population (in %) of El Salvador in 2011 to that in 2012?
Offer a terse response. 1.03. What is the ratio of the Population (in %) of Thailand in 2011 to that in 2012?
Your answer should be compact. 1.02. What is the ratio of the Population (in %) of Bahrain in 2011 to that in 2013?
Keep it short and to the point. 0.96. What is the ratio of the Population (in %) of El Salvador in 2011 to that in 2013?
Provide a succinct answer. 1.05. What is the ratio of the Population (in %) in Bahrain in 2011 to that in 2014?
Your answer should be very brief. 0.95. What is the ratio of the Population (in %) in El Salvador in 2011 to that in 2014?
Provide a succinct answer. 1.08. What is the ratio of the Population (in %) of Thailand in 2011 to that in 2014?
Your response must be concise. 1.05. What is the ratio of the Population (in %) in Bahrain in 2012 to that in 2013?
Ensure brevity in your answer.  0.98. What is the ratio of the Population (in %) in El Salvador in 2012 to that in 2013?
Your response must be concise. 1.03. What is the ratio of the Population (in %) of Thailand in 2012 to that in 2013?
Offer a terse response. 1.02. What is the ratio of the Population (in %) in El Salvador in 2012 to that in 2014?
Your answer should be compact. 1.05. What is the ratio of the Population (in %) of Thailand in 2012 to that in 2014?
Your answer should be very brief. 1.03. What is the ratio of the Population (in %) of El Salvador in 2013 to that in 2014?
Provide a short and direct response. 1.02. What is the ratio of the Population (in %) of Thailand in 2013 to that in 2014?
Keep it short and to the point. 1.01. What is the difference between the highest and the second highest Population (in %) in Bahrain?
Your answer should be compact. 0.53. What is the difference between the highest and the second highest Population (in %) in El Salvador?
Offer a terse response. 0.68. What is the difference between the highest and the second highest Population (in %) of Mali?
Your answer should be very brief. 0.03. What is the difference between the highest and the second highest Population (in %) in Thailand?
Give a very brief answer. 0.56. What is the difference between the highest and the lowest Population (in %) in Bahrain?
Your answer should be very brief. 2.04. What is the difference between the highest and the lowest Population (in %) in El Salvador?
Provide a succinct answer. 4.29. What is the difference between the highest and the lowest Population (in %) of Mali?
Keep it short and to the point. 0.54. What is the difference between the highest and the lowest Population (in %) in Thailand?
Keep it short and to the point. 2.29. 